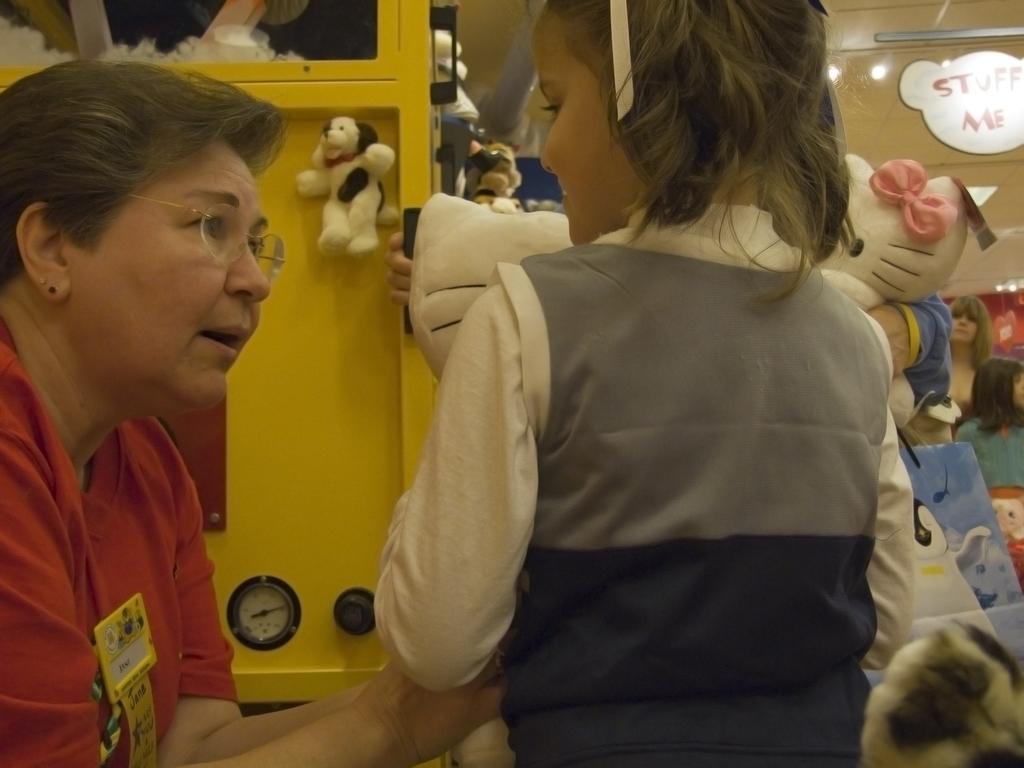Describe this image in one or two sentences. In this picture I can see a person on the right side. I can see the child. I can see the toys. I can see the metal object on the left side. 